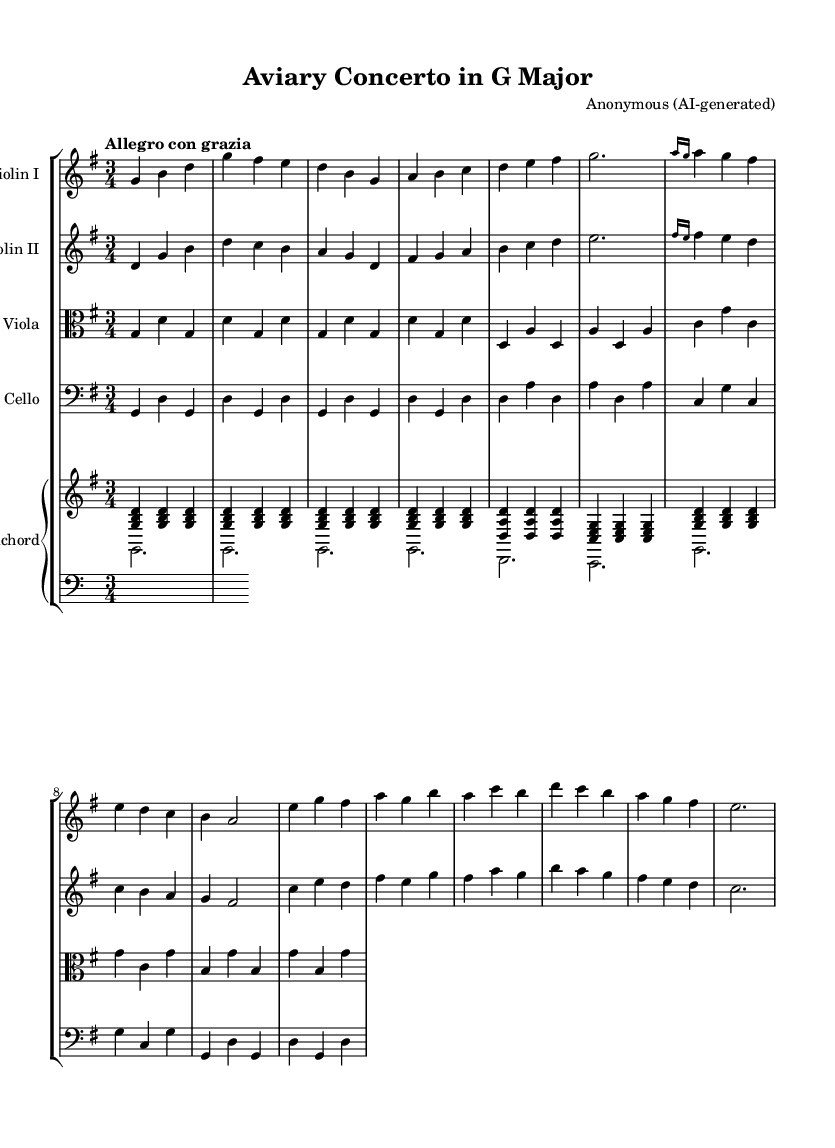What is the key signature of this music? The key signature is G major, which has one sharp (F#). You can determine this by looking at the key signature indicated at the beginning of the staff, which shows a single sharp on the staff lines.
Answer: G major What is the time signature of this piece? The time signature of this music is 3/4. This can be seen at the beginning of the score, where the top number (3) indicates three beats per measure and the bottom number (4) indicates that the quarter note gets one beat.
Answer: 3/4 What is the tempo marking for this music? The tempo marking is "Allegro con grazia." This is stated at the beginning of the score, which indicates the speed and style the piece should be played. "Allegro" suggests a fast pace, while "con grazia" means with grace.
Answer: Allegro con grazia How many instruments are used in this piece? There are five instruments used in this composition: Violin I, Violin II, Viola, Cello, and Harpsichord. This can be inferred from the staff groupings at the beginning of the score, which identifies each instrument.
Answer: Five What is the ending note of the first violin part? The ending note of the first violin part is G. Looking at the last measure of the violin I staff, you will see it concludes on the note G, which is shown as a quarter note.
Answer: G How many measures are there in total for the first violin? There are 15 measures in total for the first violin part. By counting the vertical lines (barlines) in the violin I staff, you can determine that there are 15 measures from start to finish.
Answer: 15 